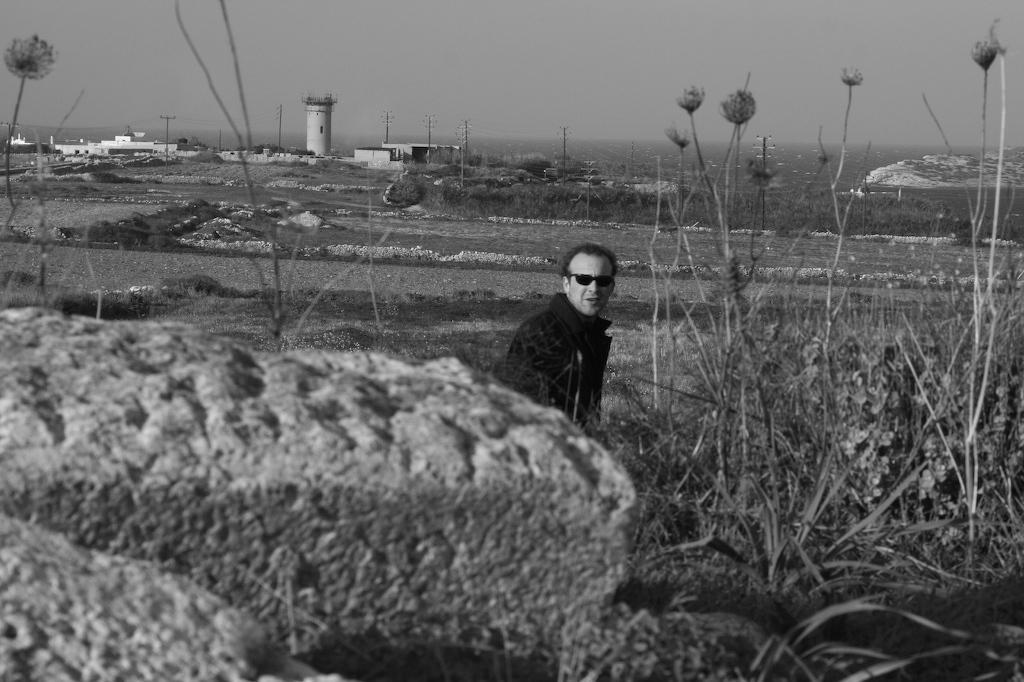How would you summarize this image in a sentence or two? It is a black and white image, in the middle a man is looking at this side. He wore coat, spectacles, there are trees in this image. 